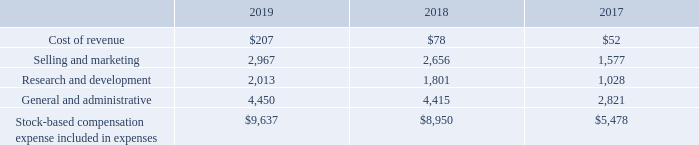Stock-based Compensation
The following table summarizes stock-based compensation expense related to RSUs, stock options, and ESPP shares for the fiscal years ended September 30, 2019, 2018, and 2017, which were allocated as follows (amounts shown in thousands):
What does the table provide for us? Stock-based compensation expense related to rsus, stock options, and espp shares for the fiscal years ended september 30, 2019, 2018, and 2017. What are the stock-based compensation expenses for research and development in 2017, 2018, and 2019, respectively?
Answer scale should be: thousand. 1,028, 1,801, 2,013. What is the stock-based compensation expenses for selling and marketing in 2018?
Answer scale should be: thousand. 2,656. What is the percentage change in the cost of revenue between 2017 and 2019?
Answer scale should be: percent. (207-52)/52 
Answer: 298.08. What is the average expense of general and administrative from 2017 to 2019?
Answer scale should be: thousand. (4,450+4,415+2,821)/3 
Answer: 3895.33. What is the proportion of selling and marketing, as well as general and administrative over total stock-based compensation expense in 2017? (1,577+2,821)/5,478 
Answer: 0.8. 